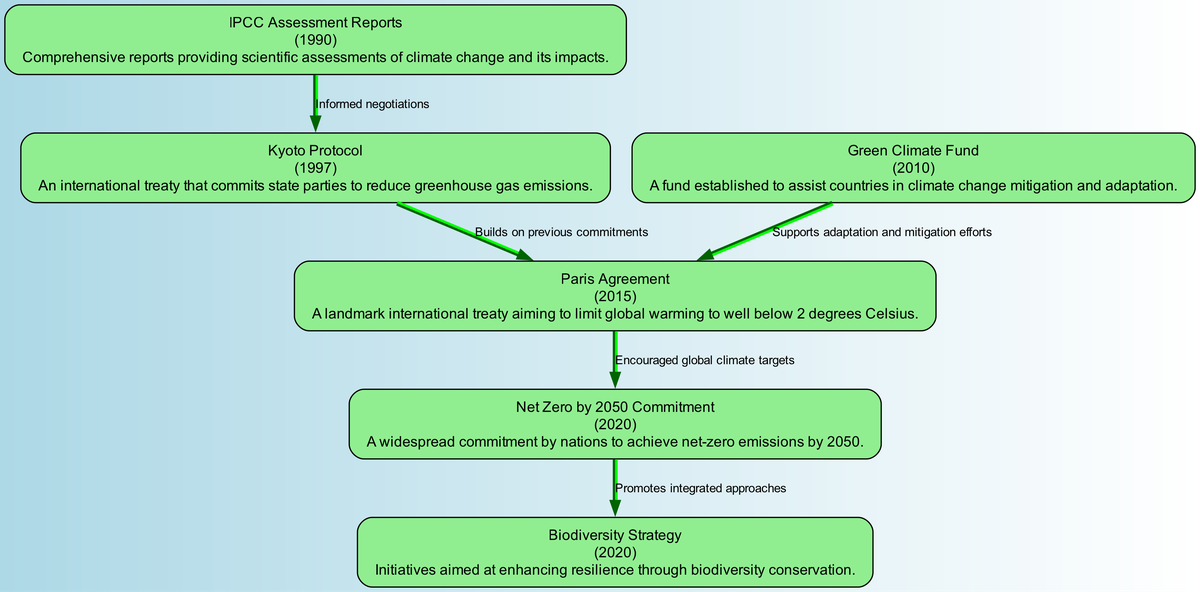What is the year of the Paris Agreement? The diagram specifies that the Paris Agreement was established in 2015. Therefore, the answer is directly derived from the node information.
Answer: 2015 How many nodes are displayed in the diagram? By counting the number of nodes listed in the data, we find there are 6 nodes: Paris Agreement, Kyoto Protocol, IPCC Assessment Reports, Green Climate Fund, Net Zero by 2050 Commitment, and Biodiversity Strategy.
Answer: 6 What is the relationship between the Kyoto Protocol and the Paris Agreement? The edge between these two nodes indicates that the Kyoto Protocol 'builds on previous commitments' leading to the Paris Agreement. This shows a direct linkage in strategy evolution.
Answer: Builds on previous commitments What innovative strategy is promoted by the Net Zero by 2050 Commitment? According to the diagram, the Net Zero by 2050 Commitment promotes 'integrated approaches' as indicated by the relationship flowing towards the Biodiversity Strategy. This implies a strategic linkage for resilience.
Answer: Integrated approaches What was established in 2010 to assist countries in climate action? Within the node descriptions, it states that the Green Climate Fund was established in 2010, highlighting its role in aiding nations with climate change efforts.
Answer: Green Climate Fund How do the IPCC Assessment Reports relate to the Kyoto Protocol? The edge from IPCC Assessment Reports to the Kyoto Protocol signifies that the reports informed the negotiations leading to the establishment of the protocol. This connection emphasizes the importance of scientific assessments in policy formation.
Answer: Informed negotiations Which node directly supports the Paris Agreement? The diagram indicates a direct edge from the Green Climate Fund to the Paris Agreement, specifying that it supports adaptation and mitigation efforts, vital for achieving the goals of the agreement.
Answer: Green Climate Fund What is the significance of the Biodiversity Strategy in relation to the Net Zero by 2050 Commitment? The edge between these nodes in the diagram shows that the Net Zero by 2050 Commitment promotes the Biodiversity Strategy, suggesting that strategies for achieving net-zero emissions incorporate biodiversity considerations for resilience.
Answer: Promotes integrated approaches 